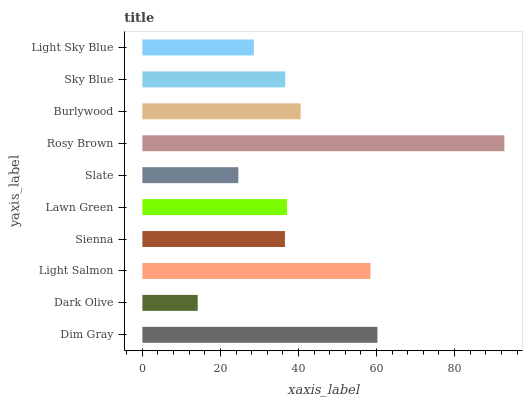Is Dark Olive the minimum?
Answer yes or no. Yes. Is Rosy Brown the maximum?
Answer yes or no. Yes. Is Light Salmon the minimum?
Answer yes or no. No. Is Light Salmon the maximum?
Answer yes or no. No. Is Light Salmon greater than Dark Olive?
Answer yes or no. Yes. Is Dark Olive less than Light Salmon?
Answer yes or no. Yes. Is Dark Olive greater than Light Salmon?
Answer yes or no. No. Is Light Salmon less than Dark Olive?
Answer yes or no. No. Is Lawn Green the high median?
Answer yes or no. Yes. Is Sky Blue the low median?
Answer yes or no. Yes. Is Dim Gray the high median?
Answer yes or no. No. Is Slate the low median?
Answer yes or no. No. 